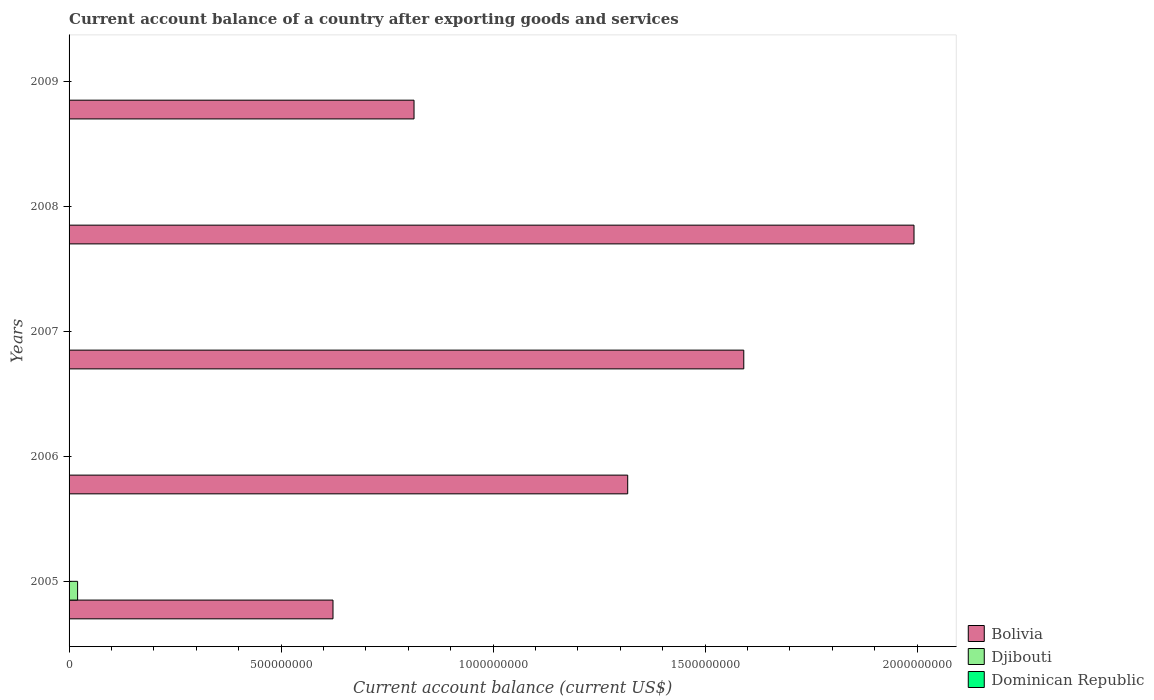How many different coloured bars are there?
Give a very brief answer. 2. Are the number of bars per tick equal to the number of legend labels?
Your answer should be very brief. No. Are the number of bars on each tick of the Y-axis equal?
Keep it short and to the point. No. In how many cases, is the number of bars for a given year not equal to the number of legend labels?
Provide a short and direct response. 5. Across all years, what is the maximum account balance in Bolivia?
Offer a very short reply. 1.99e+09. Across all years, what is the minimum account balance in Djibouti?
Keep it short and to the point. 0. In which year was the account balance in Djibouti maximum?
Ensure brevity in your answer.  2005. What is the difference between the account balance in Bolivia in 2005 and that in 2008?
Provide a succinct answer. -1.37e+09. What is the difference between the account balance in Dominican Republic in 2006 and the account balance in Bolivia in 2008?
Offer a terse response. -1.99e+09. What is the average account balance in Djibouti per year?
Ensure brevity in your answer.  4.03e+06. In how many years, is the account balance in Dominican Republic greater than 1500000000 US$?
Make the answer very short. 0. What is the ratio of the account balance in Bolivia in 2006 to that in 2007?
Provide a short and direct response. 0.83. Is the account balance in Bolivia in 2007 less than that in 2008?
Your answer should be very brief. Yes. What is the difference between the highest and the second highest account balance in Bolivia?
Your answer should be very brief. 4.01e+08. What is the difference between the highest and the lowest account balance in Bolivia?
Make the answer very short. 1.37e+09. In how many years, is the account balance in Bolivia greater than the average account balance in Bolivia taken over all years?
Provide a succinct answer. 3. Is the sum of the account balance in Bolivia in 2005 and 2007 greater than the maximum account balance in Dominican Republic across all years?
Give a very brief answer. Yes. How many bars are there?
Your answer should be very brief. 6. How many years are there in the graph?
Offer a very short reply. 5. Does the graph contain any zero values?
Provide a short and direct response. Yes. Does the graph contain grids?
Offer a terse response. No. Where does the legend appear in the graph?
Ensure brevity in your answer.  Bottom right. What is the title of the graph?
Offer a very short reply. Current account balance of a country after exporting goods and services. Does "West Bank and Gaza" appear as one of the legend labels in the graph?
Ensure brevity in your answer.  No. What is the label or title of the X-axis?
Give a very brief answer. Current account balance (current US$). What is the label or title of the Y-axis?
Give a very brief answer. Years. What is the Current account balance (current US$) in Bolivia in 2005?
Provide a short and direct response. 6.22e+08. What is the Current account balance (current US$) in Djibouti in 2005?
Make the answer very short. 2.01e+07. What is the Current account balance (current US$) in Bolivia in 2006?
Ensure brevity in your answer.  1.32e+09. What is the Current account balance (current US$) in Djibouti in 2006?
Make the answer very short. 0. What is the Current account balance (current US$) in Bolivia in 2007?
Your answer should be compact. 1.59e+09. What is the Current account balance (current US$) in Bolivia in 2008?
Keep it short and to the point. 1.99e+09. What is the Current account balance (current US$) of Dominican Republic in 2008?
Your answer should be very brief. 0. What is the Current account balance (current US$) in Bolivia in 2009?
Keep it short and to the point. 8.14e+08. Across all years, what is the maximum Current account balance (current US$) in Bolivia?
Offer a very short reply. 1.99e+09. Across all years, what is the maximum Current account balance (current US$) in Djibouti?
Ensure brevity in your answer.  2.01e+07. Across all years, what is the minimum Current account balance (current US$) of Bolivia?
Keep it short and to the point. 6.22e+08. Across all years, what is the minimum Current account balance (current US$) of Djibouti?
Make the answer very short. 0. What is the total Current account balance (current US$) in Bolivia in the graph?
Provide a short and direct response. 6.34e+09. What is the total Current account balance (current US$) of Djibouti in the graph?
Keep it short and to the point. 2.01e+07. What is the difference between the Current account balance (current US$) in Bolivia in 2005 and that in 2006?
Provide a succinct answer. -6.95e+08. What is the difference between the Current account balance (current US$) of Bolivia in 2005 and that in 2007?
Provide a succinct answer. -9.69e+08. What is the difference between the Current account balance (current US$) in Bolivia in 2005 and that in 2008?
Your answer should be very brief. -1.37e+09. What is the difference between the Current account balance (current US$) in Bolivia in 2005 and that in 2009?
Offer a terse response. -1.91e+08. What is the difference between the Current account balance (current US$) of Bolivia in 2006 and that in 2007?
Provide a short and direct response. -2.74e+08. What is the difference between the Current account balance (current US$) in Bolivia in 2006 and that in 2008?
Offer a terse response. -6.75e+08. What is the difference between the Current account balance (current US$) in Bolivia in 2006 and that in 2009?
Make the answer very short. 5.04e+08. What is the difference between the Current account balance (current US$) of Bolivia in 2007 and that in 2008?
Give a very brief answer. -4.01e+08. What is the difference between the Current account balance (current US$) in Bolivia in 2007 and that in 2009?
Provide a succinct answer. 7.78e+08. What is the difference between the Current account balance (current US$) in Bolivia in 2008 and that in 2009?
Provide a short and direct response. 1.18e+09. What is the average Current account balance (current US$) of Bolivia per year?
Make the answer very short. 1.27e+09. What is the average Current account balance (current US$) of Djibouti per year?
Your response must be concise. 4.03e+06. In the year 2005, what is the difference between the Current account balance (current US$) of Bolivia and Current account balance (current US$) of Djibouti?
Give a very brief answer. 6.02e+08. What is the ratio of the Current account balance (current US$) of Bolivia in 2005 to that in 2006?
Ensure brevity in your answer.  0.47. What is the ratio of the Current account balance (current US$) of Bolivia in 2005 to that in 2007?
Your answer should be compact. 0.39. What is the ratio of the Current account balance (current US$) in Bolivia in 2005 to that in 2008?
Offer a terse response. 0.31. What is the ratio of the Current account balance (current US$) in Bolivia in 2005 to that in 2009?
Give a very brief answer. 0.77. What is the ratio of the Current account balance (current US$) of Bolivia in 2006 to that in 2007?
Your answer should be very brief. 0.83. What is the ratio of the Current account balance (current US$) in Bolivia in 2006 to that in 2008?
Ensure brevity in your answer.  0.66. What is the ratio of the Current account balance (current US$) of Bolivia in 2006 to that in 2009?
Your response must be concise. 1.62. What is the ratio of the Current account balance (current US$) in Bolivia in 2007 to that in 2008?
Provide a short and direct response. 0.8. What is the ratio of the Current account balance (current US$) in Bolivia in 2007 to that in 2009?
Provide a succinct answer. 1.96. What is the ratio of the Current account balance (current US$) of Bolivia in 2008 to that in 2009?
Provide a short and direct response. 2.45. What is the difference between the highest and the second highest Current account balance (current US$) in Bolivia?
Offer a terse response. 4.01e+08. What is the difference between the highest and the lowest Current account balance (current US$) in Bolivia?
Your response must be concise. 1.37e+09. What is the difference between the highest and the lowest Current account balance (current US$) in Djibouti?
Ensure brevity in your answer.  2.01e+07. 